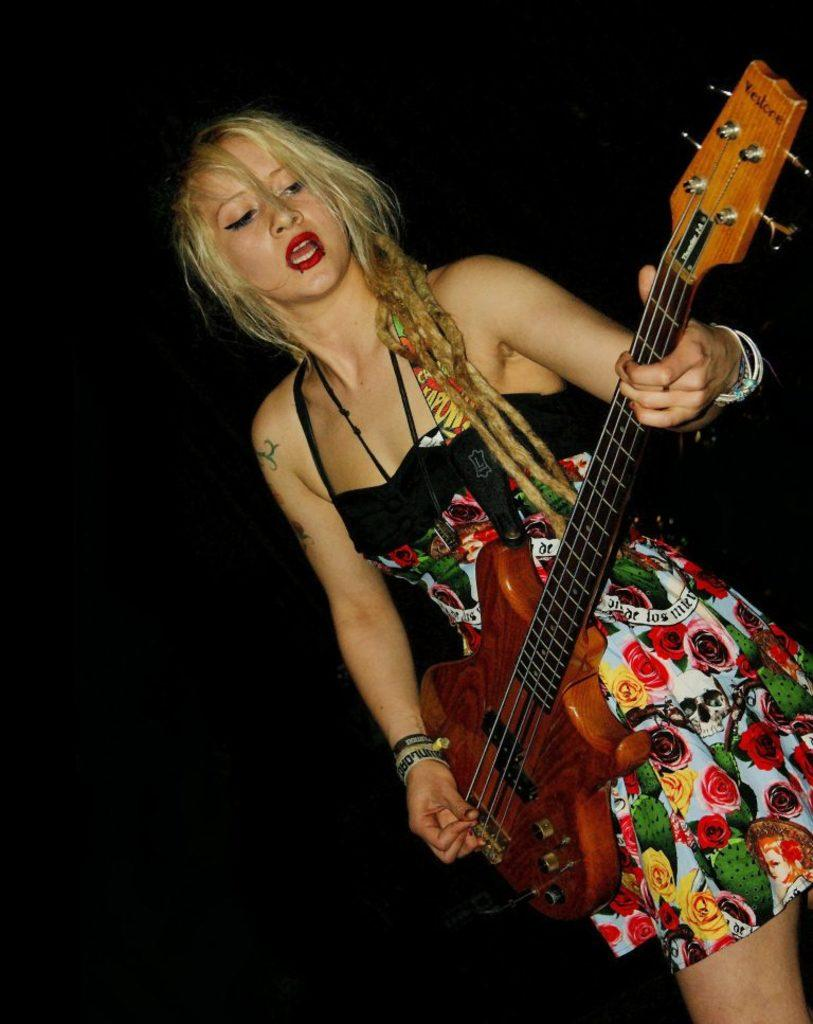Who is the main subject in the image? There is a woman in the image. What is the woman wearing? The woman is wearing a frock. What is the woman holding in the image? The woman is holding a guitar. What is the woman doing with the guitar? The woman is playing the guitar. What can be observed about the woman's appearance? The woman has red lipstick. What is the color of the background in the image? The background of the image is black. How many kites can be seen in the image? There are no kites present in the image. What type of list is the woman holding in the image? There is no list visible in the image. 